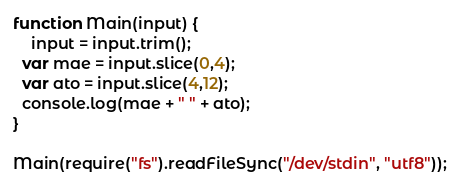Convert code to text. <code><loc_0><loc_0><loc_500><loc_500><_JavaScript_>function Main(input) {
	input = input.trim();
  var mae = input.slice(0,4);
  var ato = input.slice(4,12);
  console.log(mae + " " + ato);
}

Main(require("fs").readFileSync("/dev/stdin", "utf8"));
</code> 